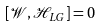Convert formula to latex. <formula><loc_0><loc_0><loc_500><loc_500>[ \mathcal { W } , \mathcal { H } _ { L G } ] = 0</formula> 